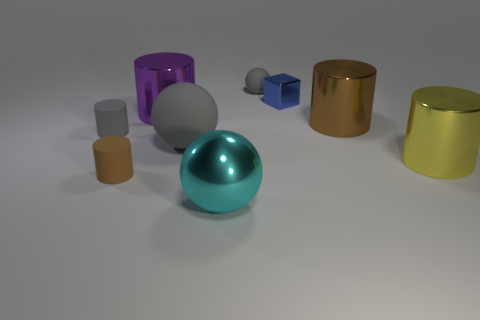The other big thing that is the same shape as the large rubber thing is what color? The other large object that shares the same spherical shape as the prominent rubber item in the image is colored in a glossy shade of teal. This vibrant color stands out against the more muted tones of the other objects in the composition. 